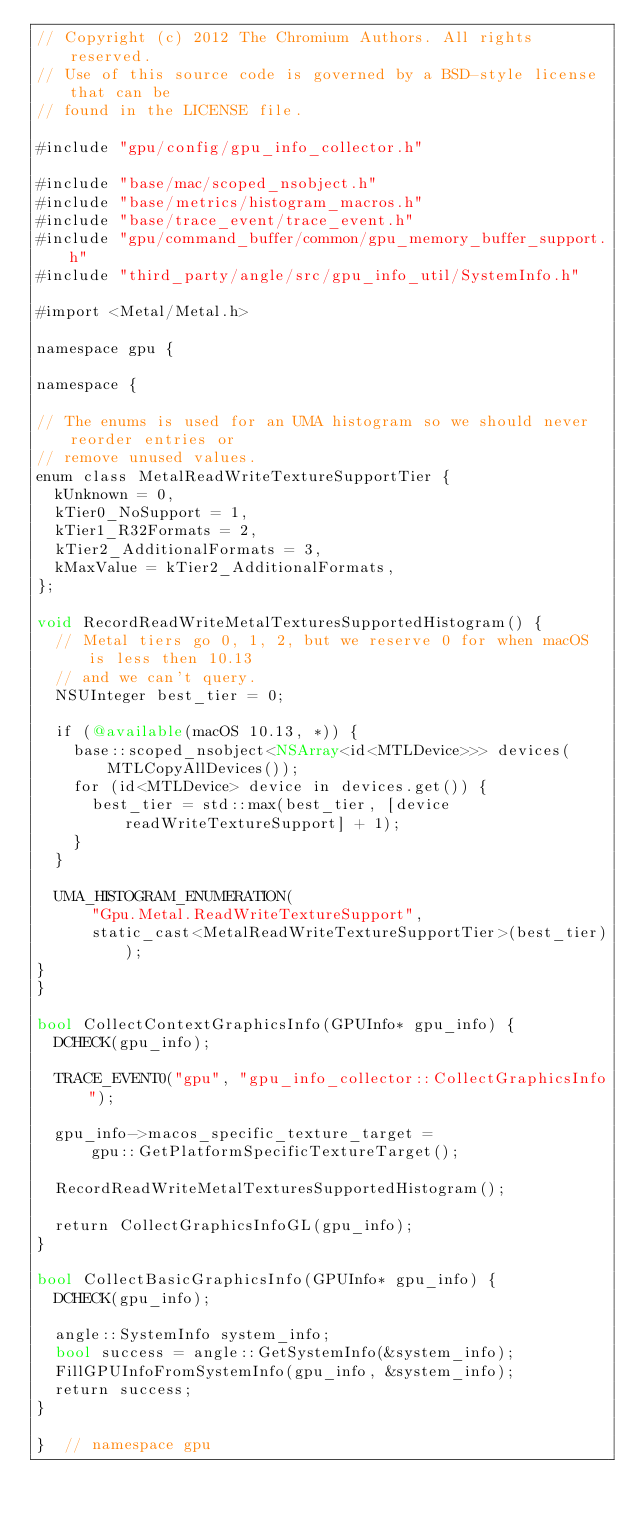Convert code to text. <code><loc_0><loc_0><loc_500><loc_500><_ObjectiveC_>// Copyright (c) 2012 The Chromium Authors. All rights reserved.
// Use of this source code is governed by a BSD-style license that can be
// found in the LICENSE file.

#include "gpu/config/gpu_info_collector.h"

#include "base/mac/scoped_nsobject.h"
#include "base/metrics/histogram_macros.h"
#include "base/trace_event/trace_event.h"
#include "gpu/command_buffer/common/gpu_memory_buffer_support.h"
#include "third_party/angle/src/gpu_info_util/SystemInfo.h"

#import <Metal/Metal.h>

namespace gpu {

namespace {

// The enums is used for an UMA histogram so we should never reorder entries or
// remove unused values.
enum class MetalReadWriteTextureSupportTier {
  kUnknown = 0,
  kTier0_NoSupport = 1,
  kTier1_R32Formats = 2,
  kTier2_AdditionalFormats = 3,
  kMaxValue = kTier2_AdditionalFormats,
};

void RecordReadWriteMetalTexturesSupportedHistogram() {
  // Metal tiers go 0, 1, 2, but we reserve 0 for when macOS is less then 10.13
  // and we can't query.
  NSUInteger best_tier = 0;

  if (@available(macOS 10.13, *)) {
    base::scoped_nsobject<NSArray<id<MTLDevice>>> devices(MTLCopyAllDevices());
    for (id<MTLDevice> device in devices.get()) {
      best_tier = std::max(best_tier, [device readWriteTextureSupport] + 1);
    }
  }

  UMA_HISTOGRAM_ENUMERATION(
      "Gpu.Metal.ReadWriteTextureSupport",
      static_cast<MetalReadWriteTextureSupportTier>(best_tier));
}
}

bool CollectContextGraphicsInfo(GPUInfo* gpu_info) {
  DCHECK(gpu_info);

  TRACE_EVENT0("gpu", "gpu_info_collector::CollectGraphicsInfo");

  gpu_info->macos_specific_texture_target =
      gpu::GetPlatformSpecificTextureTarget();

  RecordReadWriteMetalTexturesSupportedHistogram();

  return CollectGraphicsInfoGL(gpu_info);
}

bool CollectBasicGraphicsInfo(GPUInfo* gpu_info) {
  DCHECK(gpu_info);

  angle::SystemInfo system_info;
  bool success = angle::GetSystemInfo(&system_info);
  FillGPUInfoFromSystemInfo(gpu_info, &system_info);
  return success;
}

}  // namespace gpu
</code> 